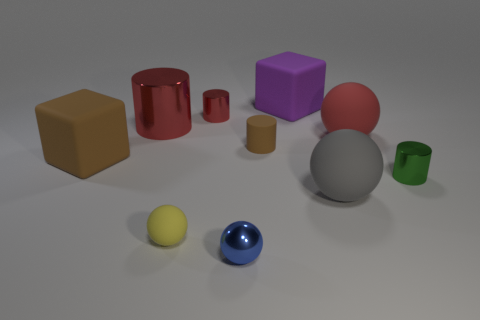What material is the big ball that is right of the large ball that is to the left of the big red rubber sphere? The big ball to the right of the large ball, located to the left of the big red rubber sphere, appears to be made of a matte plastic material, distinguishable by its slightly dull surface and the way it diffuses light as opposed to reflecting it. 